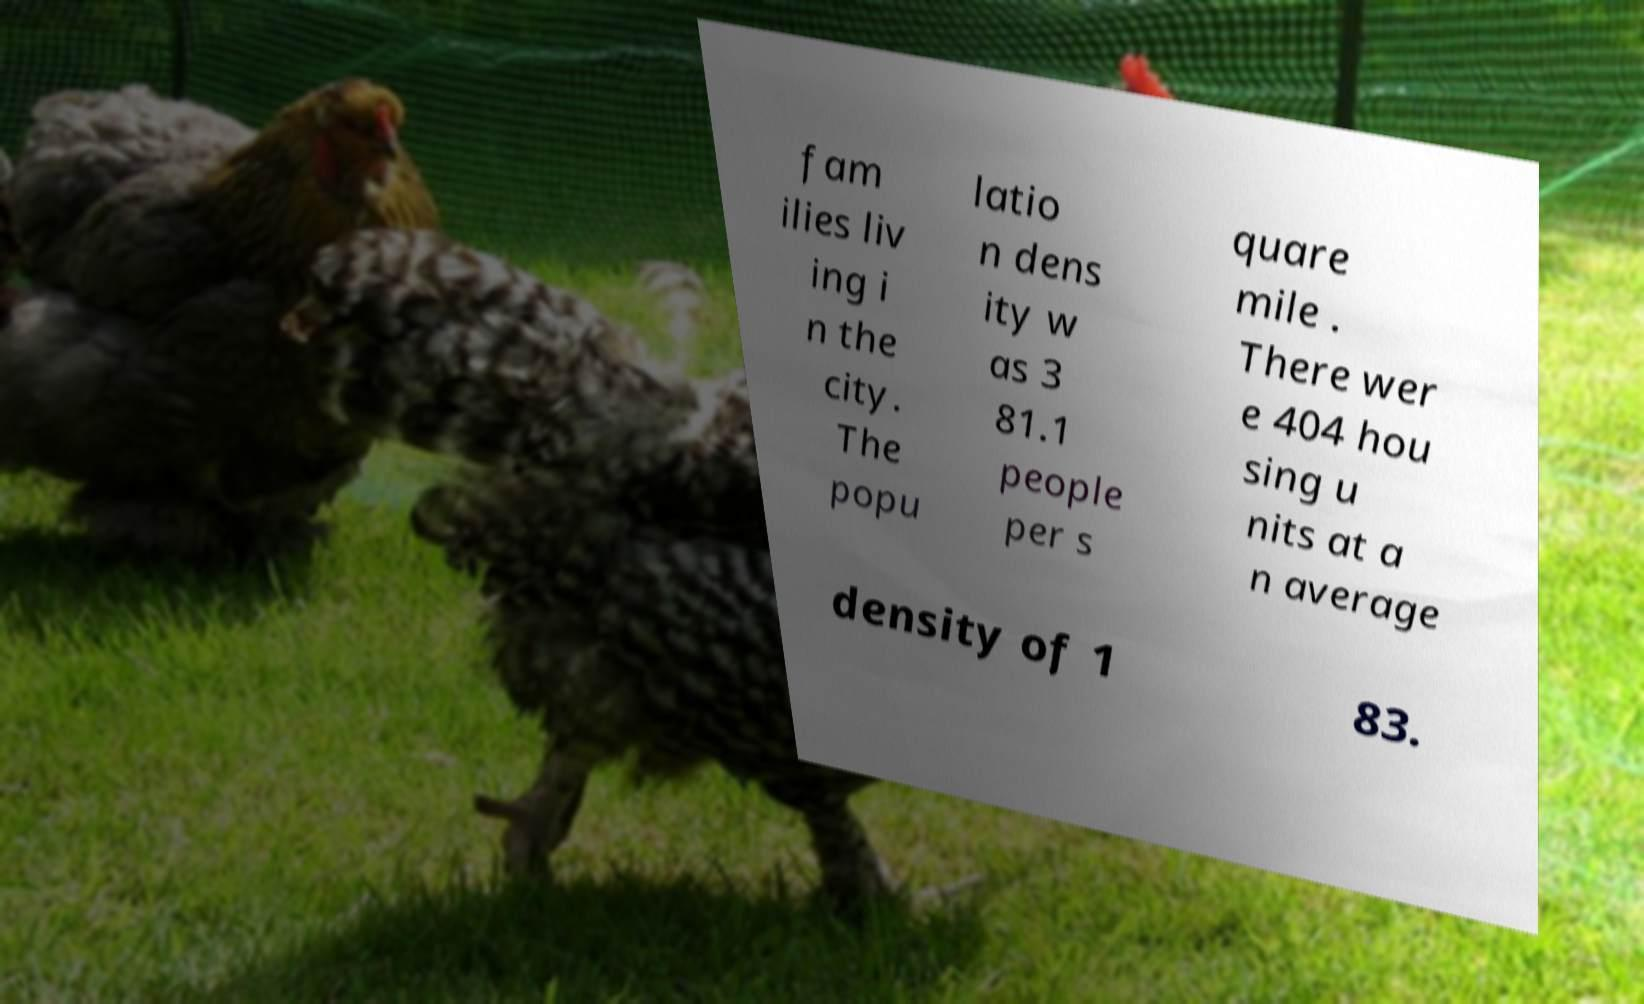For documentation purposes, I need the text within this image transcribed. Could you provide that? fam ilies liv ing i n the city. The popu latio n dens ity w as 3 81.1 people per s quare mile . There wer e 404 hou sing u nits at a n average density of 1 83. 